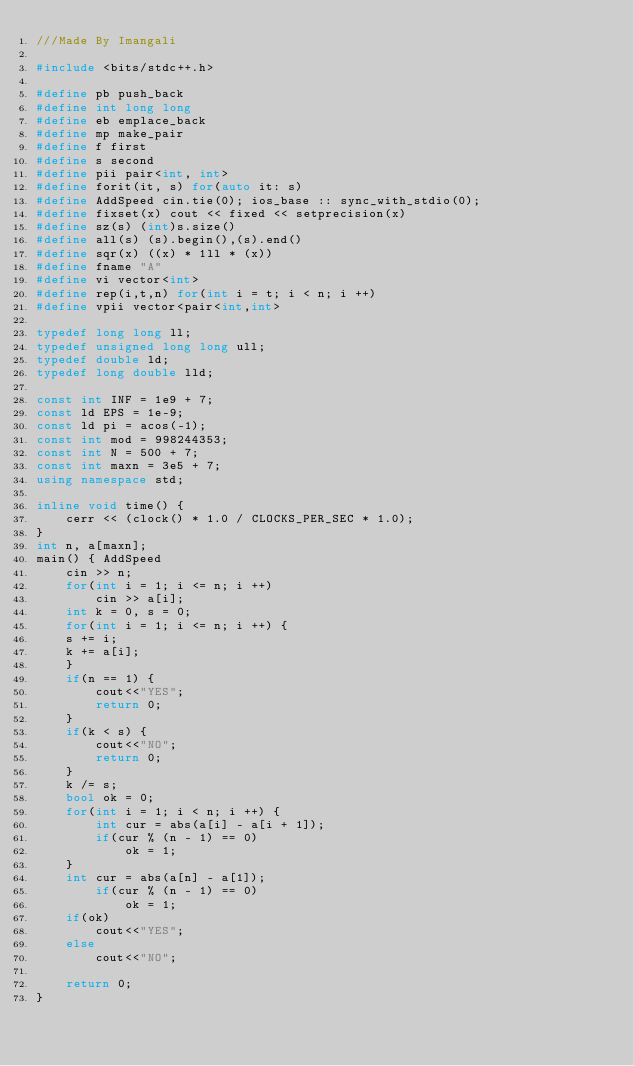Convert code to text. <code><loc_0><loc_0><loc_500><loc_500><_C++_>///Made By Imangali

#include <bits/stdc++.h>

#define pb push_back
#define int long long
#define eb emplace_back
#define mp make_pair
#define f first
#define s second
#define pii pair<int, int>
#define forit(it, s) for(auto it: s)
#define AddSpeed cin.tie(0); ios_base :: sync_with_stdio(0);
#define fixset(x) cout << fixed << setprecision(x)
#define sz(s) (int)s.size()
#define all(s) (s).begin(),(s).end()
#define sqr(x) ((x) * 1ll * (x))
#define fname "A"
#define vi vector<int>
#define rep(i,t,n) for(int i = t; i < n; i ++)
#define vpii vector<pair<int,int>                         

typedef long long ll;
typedef unsigned long long ull;
typedef double ld;
typedef long double lld;

const int INF = 1e9 + 7;
const ld EPS = 1e-9;
const ld pi = acos(-1);
const int mod = 998244353;
const int N = 500 + 7;
const int maxn = 3e5 + 7;
using namespace std;

inline void time() {
	cerr << (clock() * 1.0 / CLOCKS_PER_SEC * 1.0);
}
int n, a[maxn];
main() { AddSpeed
	cin >> n;
	for(int i = 1; i <= n; i ++)
		cin >> a[i];
	int k = 0, s = 0;
 	for(int i = 1; i <= n; i ++) {
  	s += i;
  	k += a[i];
	}
	if(n == 1) {
		cout<<"YES";
		return 0;
	}
	if(k < s) {
		cout<<"NO";
		return 0;
	}
	k /= s;
	bool ok = 0;
	for(int i = 1; i < n; i ++) {
		int cur = abs(a[i] - a[i + 1]);
		if(cur % (n - 1) == 0)
			ok = 1;
	}
	int cur = abs(a[n] - a[1]);
		if(cur % (n - 1) == 0)
			ok = 1;
	if(ok)
		cout<<"YES";
	else
		cout<<"NO";

	return 0;                                                                                                           
}</code> 